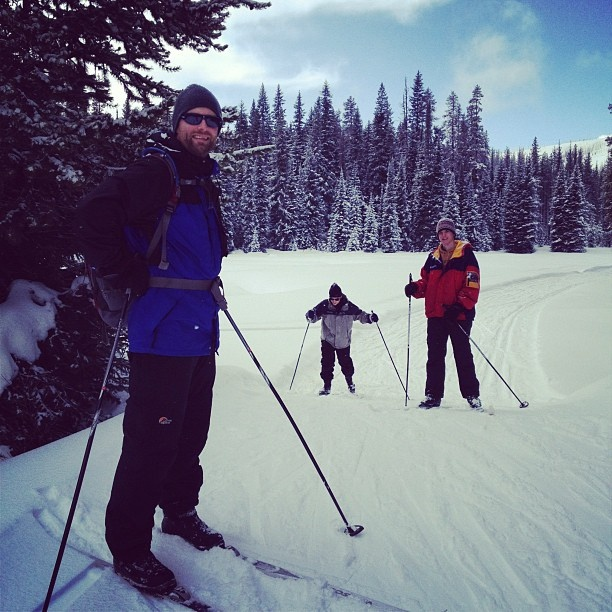Describe the objects in this image and their specific colors. I can see people in black, navy, and purple tones, people in black, navy, purple, and lightgray tones, skis in black, darkgray, gray, and purple tones, backpack in black, navy, and purple tones, and people in black, navy, purple, gray, and lightgray tones in this image. 